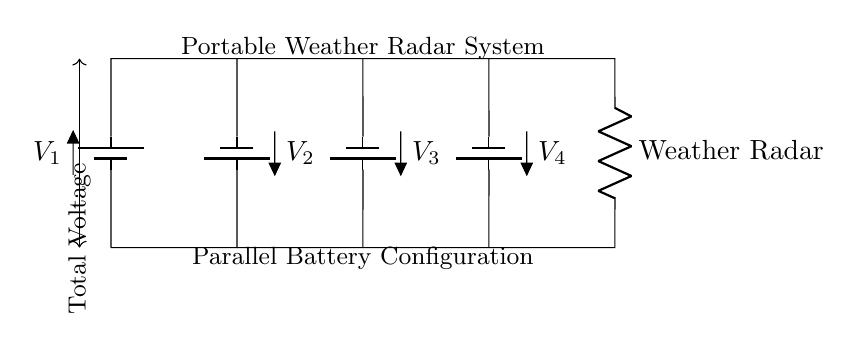What type of configuration is used in this circuit? The circuit uses a parallel configuration, where multiple batteries are connected side by side, allowing for a combined voltage while maintaining individual battery current capacity.
Answer: Parallel What is the component supplying power to the weather radar? The weather radar is powered by the batteries in parallel, allowing for sufficient voltage and current delivery from the combined output of all batteries.
Answer: Batteries How many batteries are connected in this circuit? There are four batteries shown in the diagram, each contributing to the overall voltage of the circuit as they are connected in parallel.
Answer: Four What is the function of the resistor in this circuit? The resistor is labeled as "Weather Radar," indicating that it is the load that consumes the power supplied by the batteries, allowing the circuit to provide operational functionality.
Answer: Weather Radar What is the total voltage provided by the batteries if they each have the same voltage? In a parallel configuration, the total voltage remains the same as the voltage of one battery. If each battery has a voltage of V, then the total voltage across the circuit is V.
Answer: V 